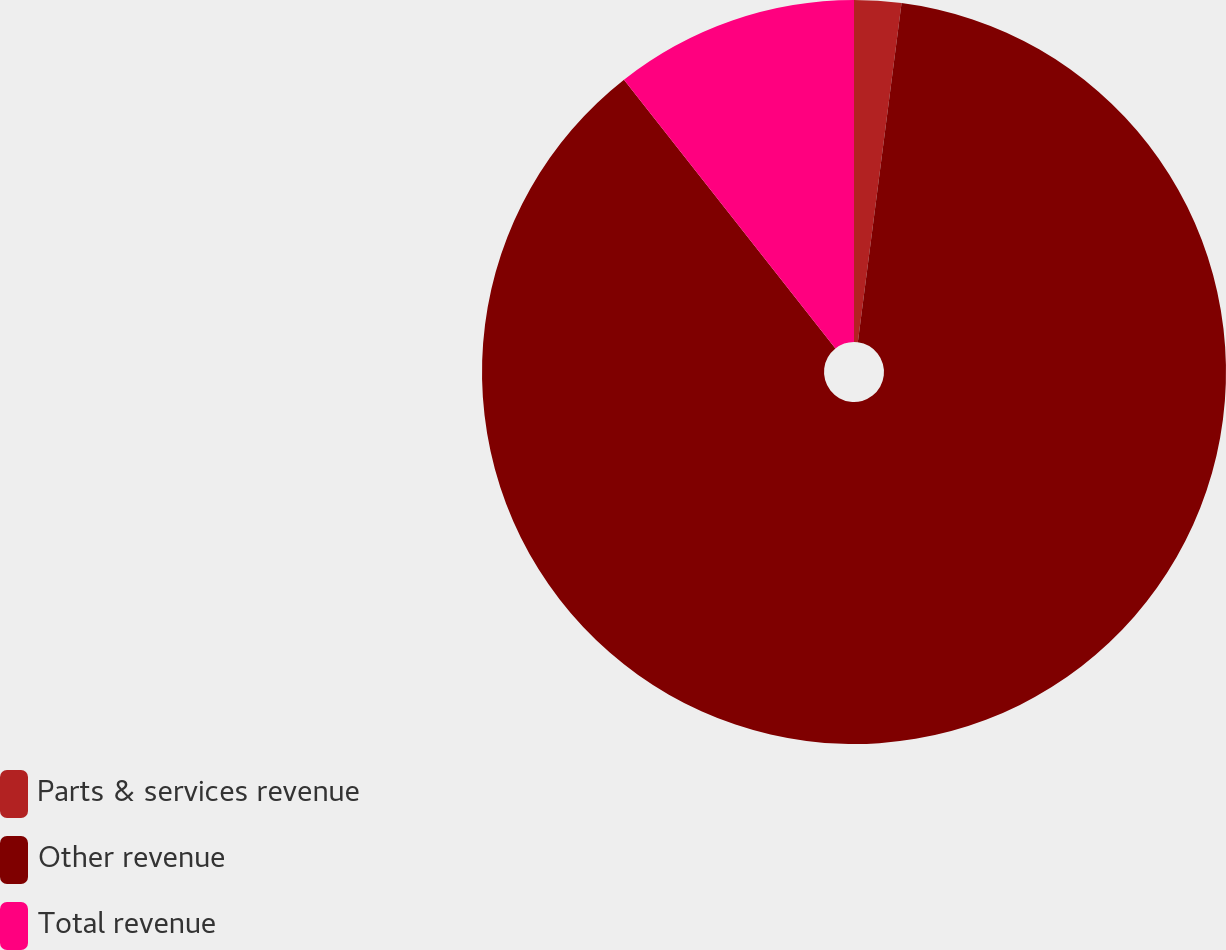Convert chart to OTSL. <chart><loc_0><loc_0><loc_500><loc_500><pie_chart><fcel>Parts & services revenue<fcel>Other revenue<fcel>Total revenue<nl><fcel>2.04%<fcel>87.35%<fcel>10.61%<nl></chart> 